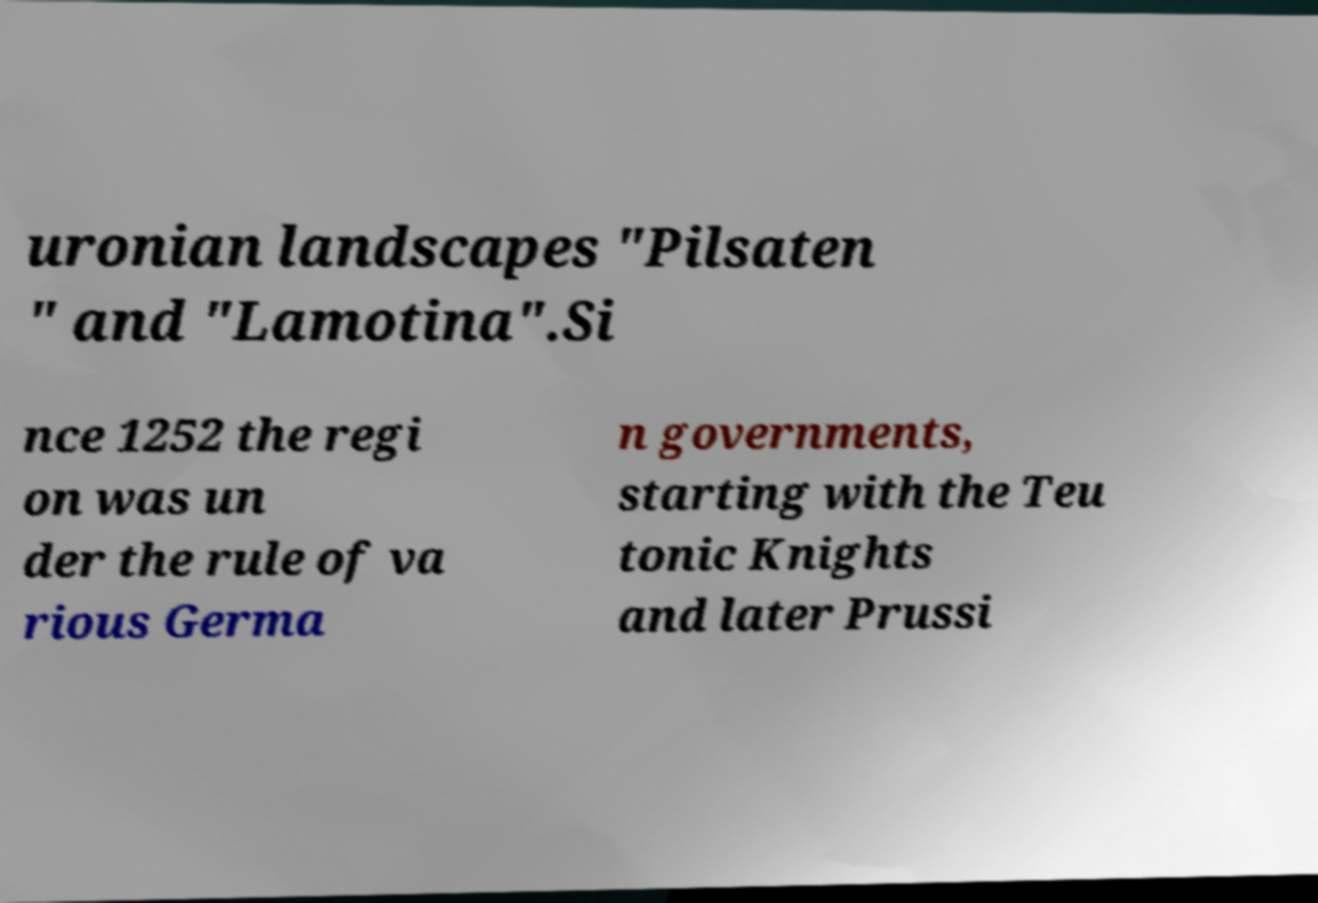Can you read and provide the text displayed in the image?This photo seems to have some interesting text. Can you extract and type it out for me? uronian landscapes "Pilsaten " and "Lamotina".Si nce 1252 the regi on was un der the rule of va rious Germa n governments, starting with the Teu tonic Knights and later Prussi 